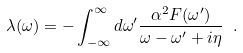Convert formula to latex. <formula><loc_0><loc_0><loc_500><loc_500>\lambda ( \omega ) = - \int _ { - \infty } ^ { \infty } d \omega ^ { \prime } \frac { \alpha ^ { 2 } F ( \omega ^ { \prime } ) } { \omega - \omega ^ { \prime } + i \eta } \ .</formula> 